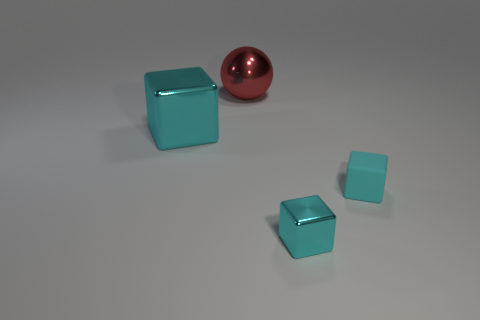Subtract all cyan cubes. How many were subtracted if there are1cyan cubes left? 2 Subtract all large cubes. How many cubes are left? 2 Subtract 1 cubes. How many cubes are left? 2 Add 4 cyan metal spheres. How many objects exist? 8 Subtract all blocks. How many objects are left? 1 Subtract 0 cyan balls. How many objects are left? 4 Subtract all brown cubes. Subtract all red spheres. How many cubes are left? 3 Subtract all metal blocks. Subtract all green matte blocks. How many objects are left? 2 Add 3 big metal cubes. How many big metal cubes are left? 4 Add 1 large balls. How many large balls exist? 2 